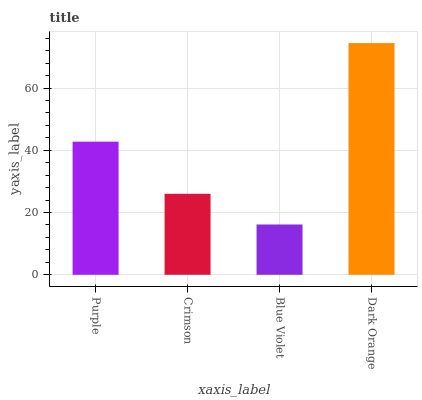Is Blue Violet the minimum?
Answer yes or no. Yes. Is Dark Orange the maximum?
Answer yes or no. Yes. Is Crimson the minimum?
Answer yes or no. No. Is Crimson the maximum?
Answer yes or no. No. Is Purple greater than Crimson?
Answer yes or no. Yes. Is Crimson less than Purple?
Answer yes or no. Yes. Is Crimson greater than Purple?
Answer yes or no. No. Is Purple less than Crimson?
Answer yes or no. No. Is Purple the high median?
Answer yes or no. Yes. Is Crimson the low median?
Answer yes or no. Yes. Is Crimson the high median?
Answer yes or no. No. Is Blue Violet the low median?
Answer yes or no. No. 